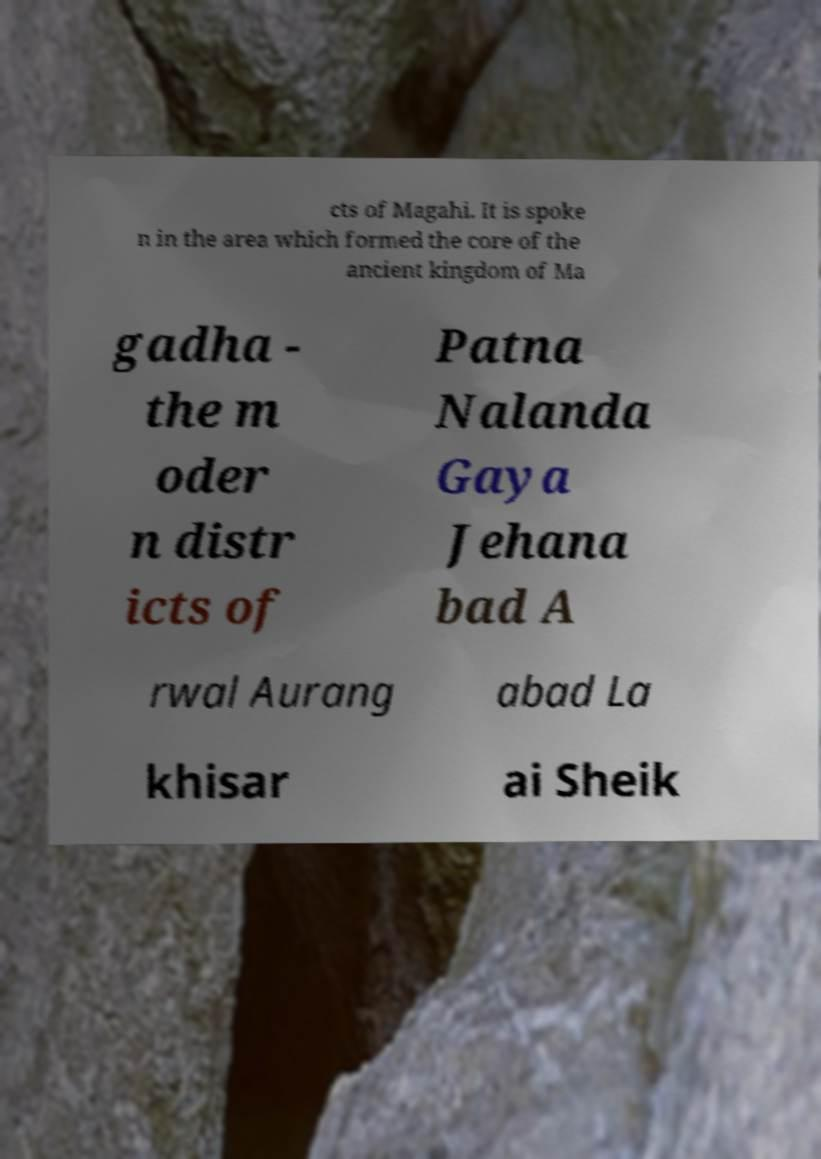Please identify and transcribe the text found in this image. cts of Magahi. It is spoke n in the area which formed the core of the ancient kingdom of Ma gadha - the m oder n distr icts of Patna Nalanda Gaya Jehana bad A rwal Aurang abad La khisar ai Sheik 